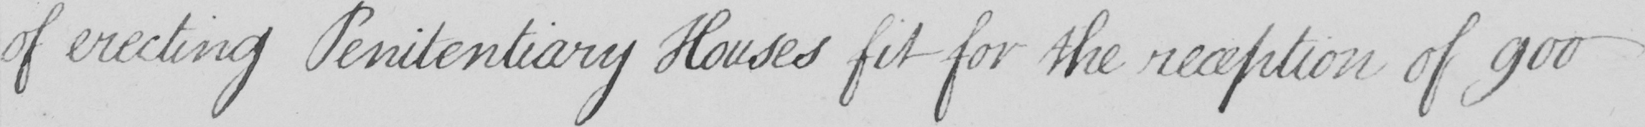What does this handwritten line say? of erecting Penitentiary Houses fit for the reception of 900 